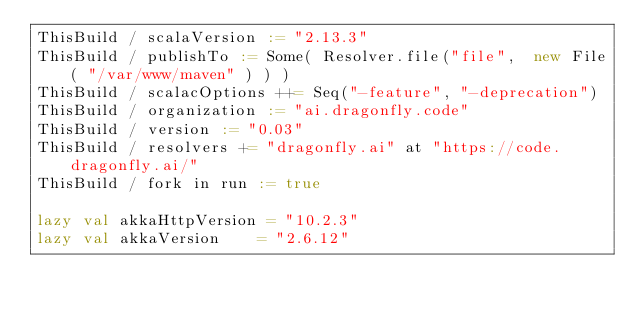Convert code to text. <code><loc_0><loc_0><loc_500><loc_500><_Scala_>ThisBuild / scalaVersion := "2.13.3"
ThisBuild / publishTo := Some( Resolver.file("file",  new File( "/var/www/maven" ) ) )
ThisBuild / scalacOptions ++= Seq("-feature", "-deprecation")
ThisBuild / organization := "ai.dragonfly.code"
ThisBuild / version := "0.03"
ThisBuild / resolvers += "dragonfly.ai" at "https://code.dragonfly.ai/"
ThisBuild / fork in run := true

lazy val akkaHttpVersion = "10.2.3"
lazy val akkaVersion    = "2.6.12"
</code> 